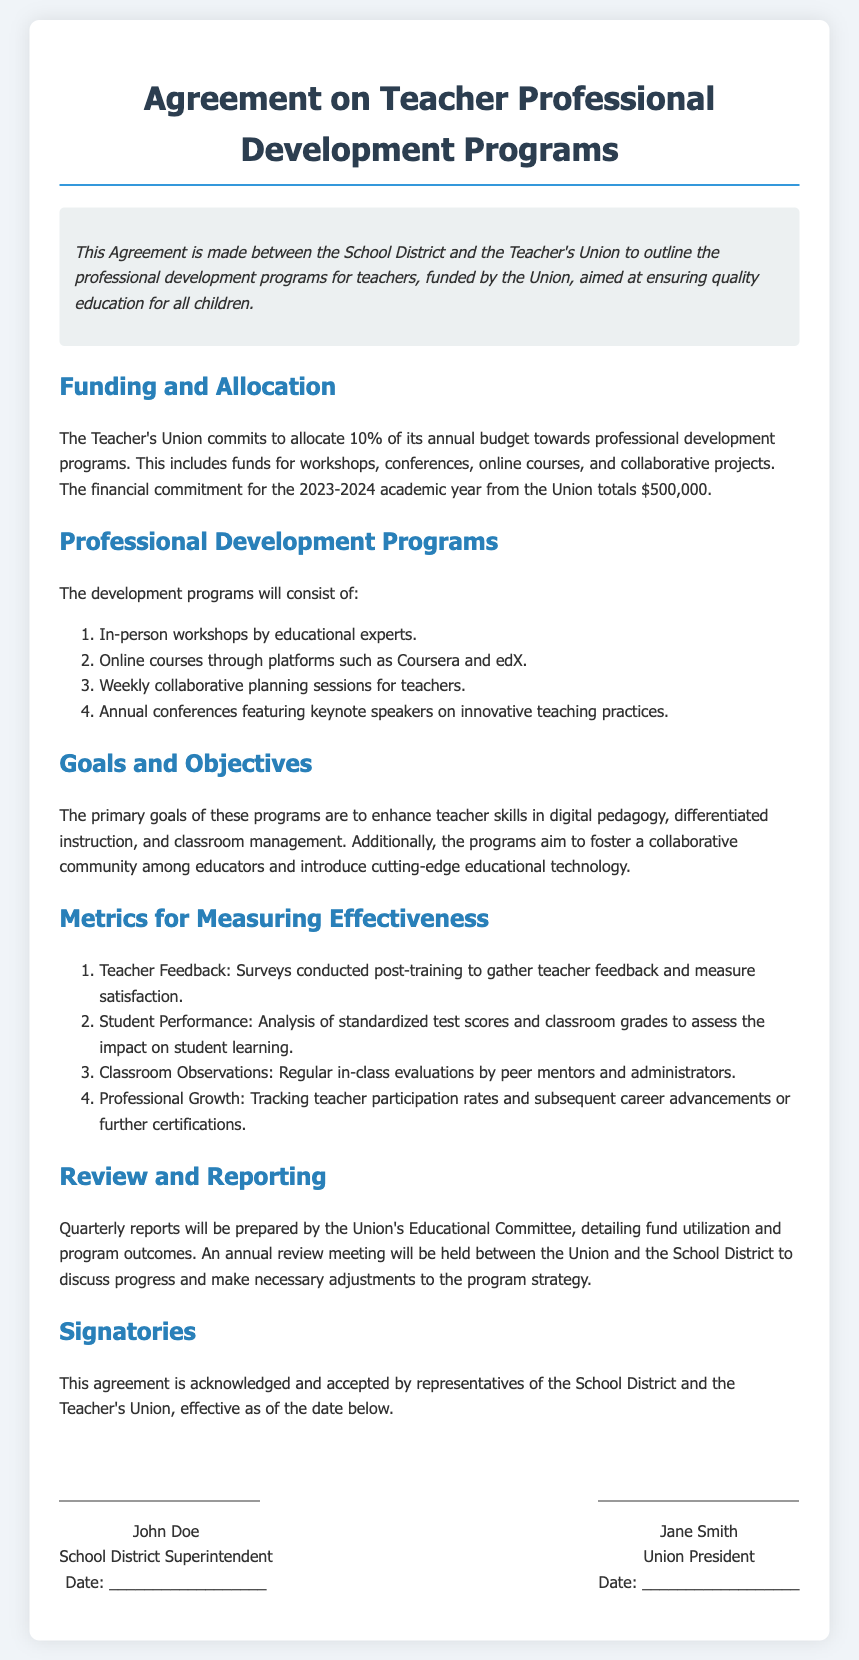What is the percentage of the budget allocated for professional development programs? The document states that the Teacher's Union commits to allocate 10% of its annual budget towards professional development programs.
Answer: 10% What is the total financial commitment from the Union for the 2023-2024 academic year? According to the document, the financial commitment for the 2023-2024 academic year from the Union totals $500,000.
Answer: $500,000 Who is the Union President? The document mentions Jane Smith as the Union President.
Answer: Jane Smith What type of courses are included in the professional development programs? The document lists online courses through platforms such as Coursera and edX as part of the programs.
Answer: Online courses What is one of the metrics for measuring effectiveness mentioned in the document? The document includes teacher feedback, which involves surveys conducted post-training to gather teacher feedback.
Answer: Teacher Feedback What is the purpose of the quarterly reports? The quarterly reports will detail fund utilization and program outcomes as stated in the document.
Answer: Fund utilization and program outcomes What is one goal of the professional development programs? A primary goal of the programs is to enhance teacher skills in digital pedagogy.
Answer: Enhance teacher skills in digital pedagogy When will the annual review meeting take place? An annual review meeting will be held to discuss progress, although the specific date is not mentioned in the document.
Answer: Annually How many types of professional development programs are listed? The document lists four types of professional development programs available to teachers.
Answer: Four types 